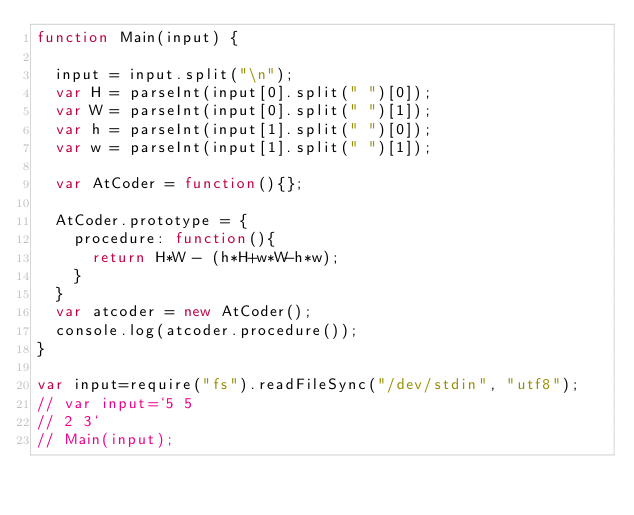Convert code to text. <code><loc_0><loc_0><loc_500><loc_500><_JavaScript_>function Main(input) {

  input = input.split("\n");
  var H = parseInt(input[0].split(" ")[0]);
  var W = parseInt(input[0].split(" ")[1]);
  var h = parseInt(input[1].split(" ")[0]);
  var w = parseInt(input[1].split(" ")[1]);

  var AtCoder = function(){};

  AtCoder.prototype = {
    procedure: function(){
      return H*W - (h*H+w*W-h*w);
    }
  }
  var atcoder = new AtCoder();
  console.log(atcoder.procedure());
}

var input=require("fs").readFileSync("/dev/stdin", "utf8");
// var input=`5 5
// 2 3`
// Main(input);
</code> 